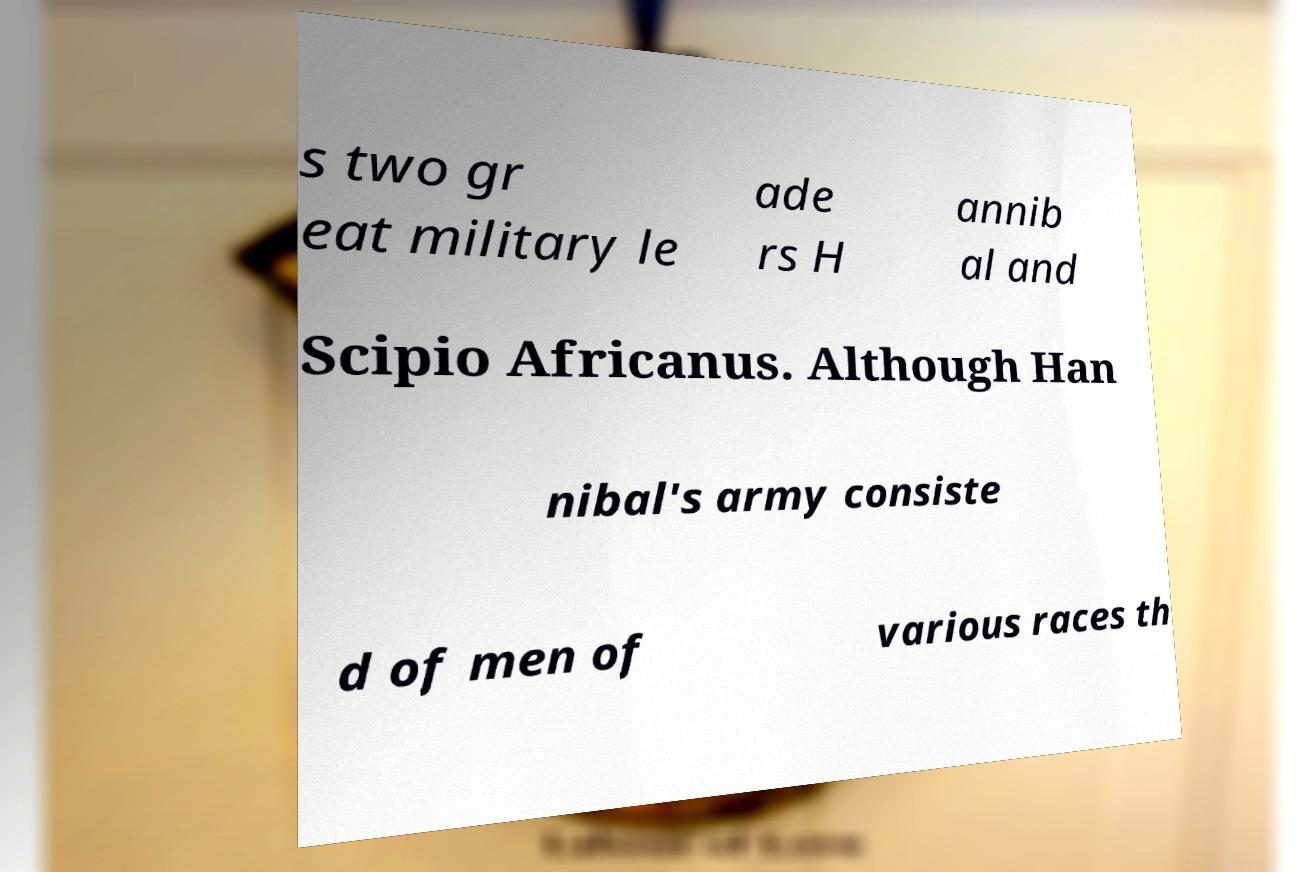For documentation purposes, I need the text within this image transcribed. Could you provide that? s two gr eat military le ade rs H annib al and Scipio Africanus. Although Han nibal's army consiste d of men of various races th 